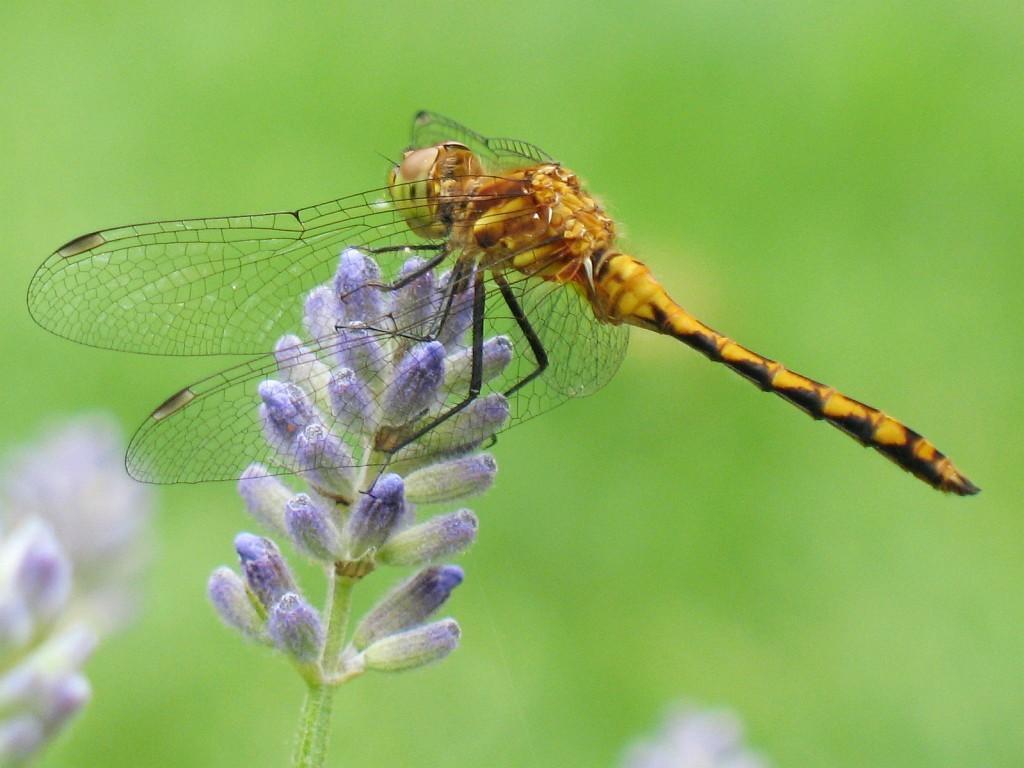How would you summarize this image in a sentence or two? In this image I see flowers which are of white and purple in color and I see an insect over here which is of brown and black in color and I see that it is totally green in the background. 